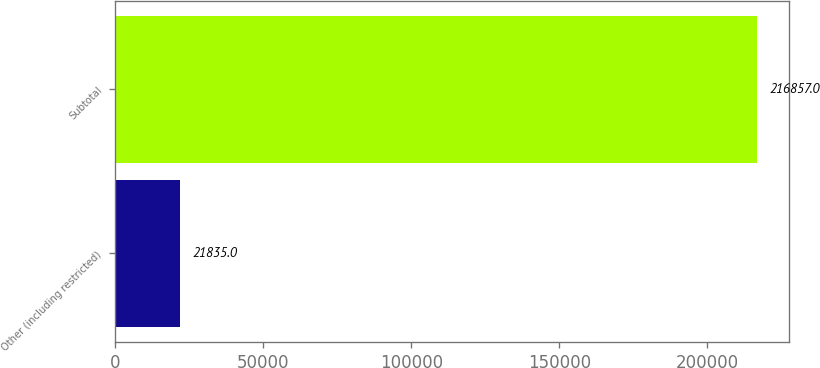Convert chart to OTSL. <chart><loc_0><loc_0><loc_500><loc_500><bar_chart><fcel>Other (including restricted)<fcel>Subtotal<nl><fcel>21835<fcel>216857<nl></chart> 